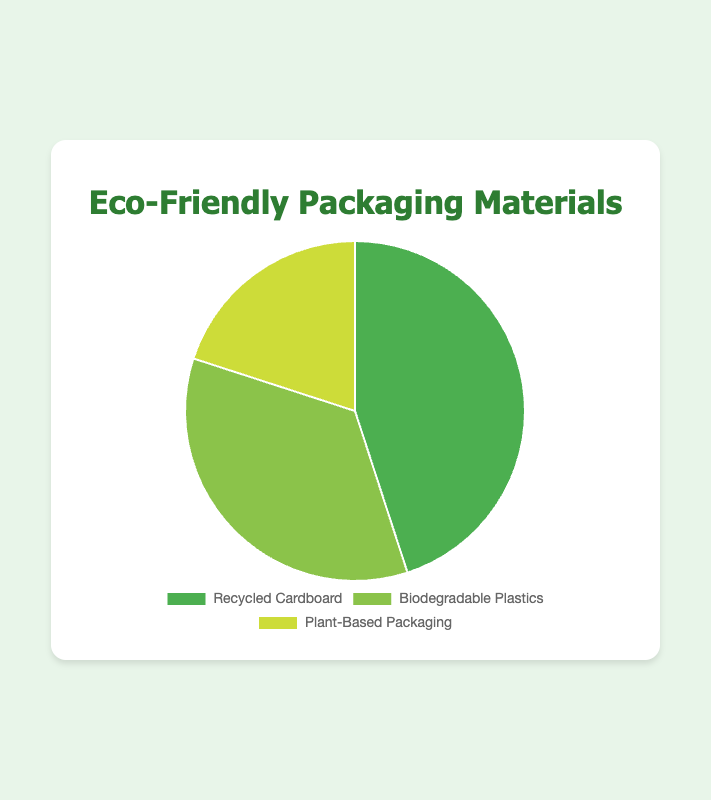Which material has the highest percentage used? The pie chart shows three types of eco-friendly packaging materials and their percentages. The material with the largest portion visually is Recycled Cardboard.
Answer: Recycled Cardboard What is the total percentage of Biodegradable Plastics and Plant-Based Packaging? The percentages for Biodegradable Plastics and Plant-Based Packaging are 35% and 20%, respectively. Summing them up yields 35 + 20 = 55%.
Answer: 55% How does the percentage of Plant-Based Packaging compare to Recycled Cardboard? The percentage for Plant-Based Packaging is 20%, and for Recycled Cardboard, it is 45%. Visually and numerically, Recycled Cardboard has a higher percentage.
Answer: Recycled Cardboard has a higher percentage Between Biodegradable Plastics and Plant-Based Packaging, which one is used more? The pie chart shows that Biodegradable Plastics is 35%, while Plant-Based Packaging is 20%. Thus, Biodegradable Plastics is used more.
Answer: Biodegradable Plastics What is the difference in percentage between the most used and least used material? The most used material is Recycled Cardboard at 45%, and the least used is Plant-Based Packaging at 20%. The difference is 45 - 20 = 25%.
Answer: 25% Calculate the average percentage of the three materials. Adding the percentages of all three materials: 45 + 35 + 20 = 100%. Dividing by the number of materials (3) gives 100 / 3 ≈ 33.33%.
Answer: 33.33% If the percentage of Biodegradable Plastics was increased by 5%, what would the new distribution look like? Increasing Biodegradable Plastics by 5% changes its percentage to 35 + 5 = 40%. This new distribution would then be Recycled Cardboard 45%, Biodegradable Plastics 40%, and Plant-Based Packaging remains 20%. Note: Total would exceed 100% without adjusting other values.
Answer: 45%, 40%, 20% (Exceeds 100%) What color represents Biodegradable Plastics in the chart? Biodegradable Plastics is marked with a unique color different from the other two materials in the pie chart. The color used for Biodegradable Plastics is green.
Answer: Green Which material section is visually the smallest in the pie chart? The pie chart visually depicts Plant-Based Packaging as having the smallest section with 20%.
Answer: Plant-Based Packaging 